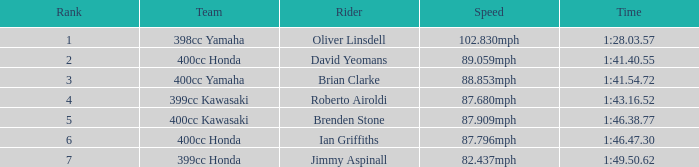What is the time of the rider ranked 6? 1:46.47.30. I'm looking to parse the entire table for insights. Could you assist me with that? {'header': ['Rank', 'Team', 'Rider', 'Speed', 'Time'], 'rows': [['1', '398cc Yamaha', 'Oliver Linsdell', '102.830mph', '1:28.03.57'], ['2', '400cc Honda', 'David Yeomans', '89.059mph', '1:41.40.55'], ['3', '400cc Yamaha', 'Brian Clarke', '88.853mph', '1:41.54.72'], ['4', '399cc Kawasaki', 'Roberto Airoldi', '87.680mph', '1:43.16.52'], ['5', '400cc Kawasaki', 'Brenden Stone', '87.909mph', '1:46.38.77'], ['6', '400cc Honda', 'Ian Griffiths', '87.796mph', '1:46.47.30'], ['7', '399cc Honda', 'Jimmy Aspinall', '82.437mph', '1:49.50.62']]} 